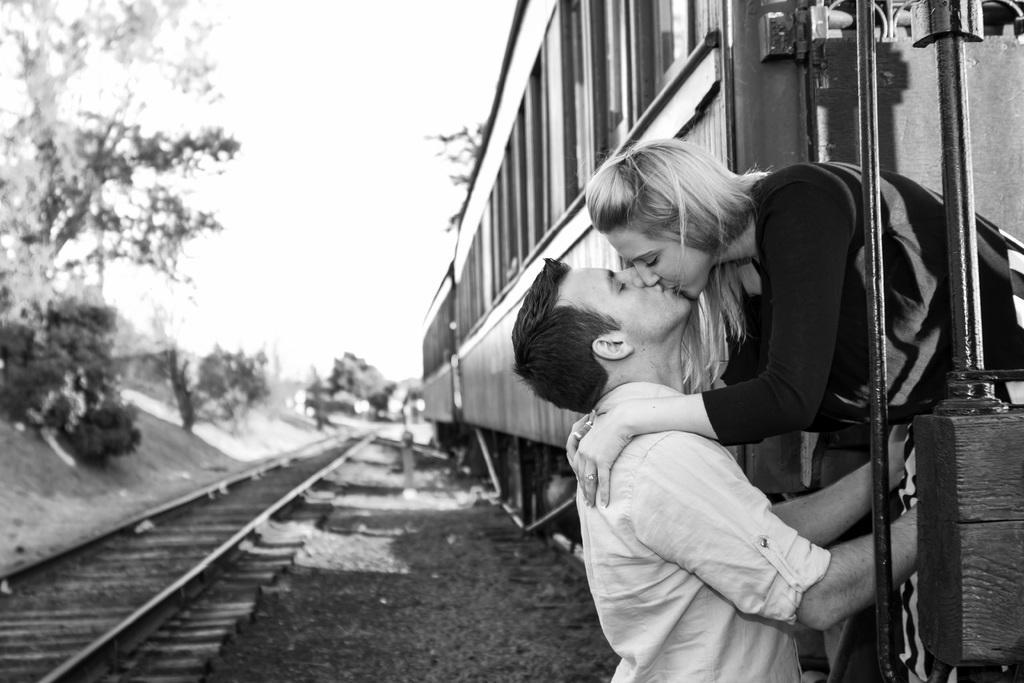Could you give a brief overview of what you see in this image? In this picture there is a girl and a boy on the right side of the image, they are kissing and there are trees on the left side of the image. 